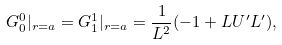<formula> <loc_0><loc_0><loc_500><loc_500>G ^ { 0 } _ { 0 } | _ { r = a } = G ^ { 1 } _ { 1 } | _ { r = a } = \frac { 1 } { L ^ { 2 } } ( - 1 + L U ^ { \prime } L ^ { \prime } ) ,</formula> 